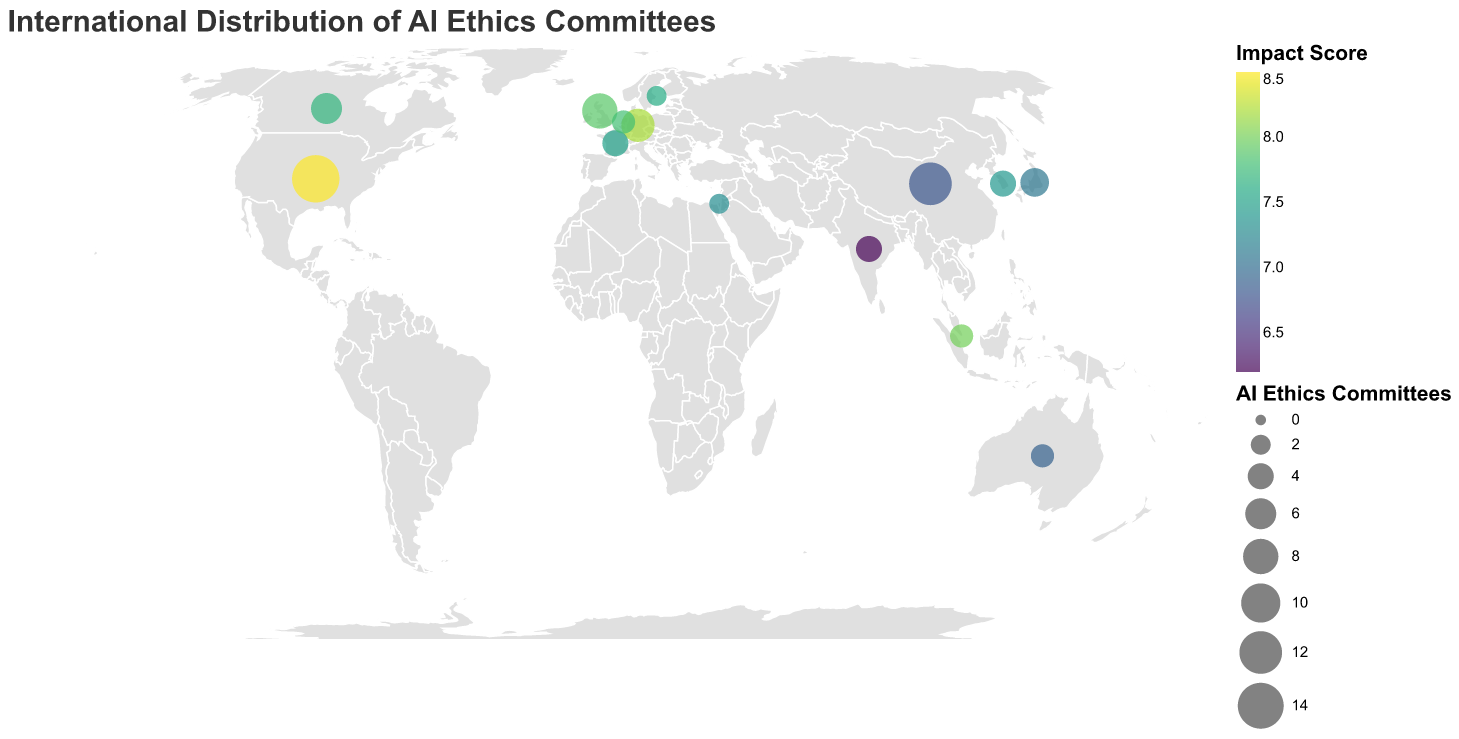What is the title of the figure? The title is often the largest text and appears at the top of the figure. It summarizes the key theme of the figure. In this case, it says, "International Distribution of AI Ethics Committees."
Answer: International Distribution of AI Ethics Committees How many AI ethics committees does the United States have? Look for the United States on the map, indicated by its coordinates and name. There is a data point or circle near its location showing the count. The size of the circle also gives a hint.
Answer: 15 Which country has the highest impact score? Look at the color coding representing impact scores. The brightest circle usually indicates the highest value. Confirm by checking the tooltip for the exact scores.
Answer: United States What is the sum of the AI ethics committees in Germany, Canada, and Japan? Identify the number of AI ethics committees in each country (Germany: 7, Canada: 6, Japan: 5), then sum them up: 7 + 6 + 5 = 18.
Answer: 18 Which country has a higher impact score, France or Australia? Compare the impact scores of France (7.5) and Australia (6.9) from their respective data points. France has a higher impact score.
Answer: France How does the impact score of China compare to that of India? Check the impact scores for China (6.8) and India (6.2). China has a higher impact score than India.
Answer: China What is the average impact score of all the represented countries? Sum all the impact scores and divide by the number of countries: (8.5 + 7.9 + 6.8 + 8.2 + 7.7 + 7.1 + 7.5 + 6.9 + 6.2 + 7.3 + 8.0 + 7.4 + 7.8 + 7.6) / 14 ≈ 7.46
Answer: 7.46 Which country’s notable policy is the "NIST AI Risk Management Framework"? Check the notable policy column for each data point in the United States.
Answer: United States How many countries have an impact score higher than 7.5? Count the number of countries with an impact score greater than 7.5: United States (8.5), United Kingdom (7.9), Germany (8.2), Singapore (8.0), and Netherlands (7.8). This results in 5 countries.
Answer: 5 Which country has the least number of AI ethics committees, and what is their impact score? Look for the country with the smallest circle, then check its corresponding impact score. Israel and Sweden both have 2 committees, with impact scores of 7.3 and 7.6 respectively.
Answer: Israel and Sweden, 7.3 and 7.6 